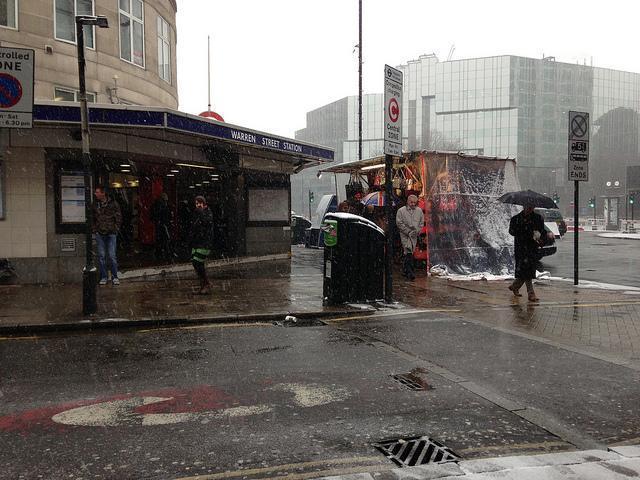How many umbrellas are open?
Give a very brief answer. 1. How many people are there?
Give a very brief answer. 2. How many bananas in the bunch?
Give a very brief answer. 0. 